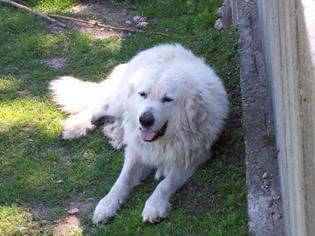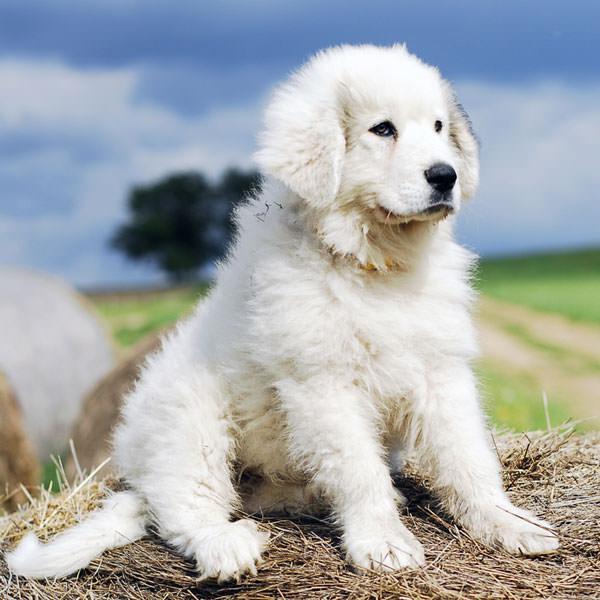The first image is the image on the left, the second image is the image on the right. Given the left and right images, does the statement "There are no more than two dogs." hold true? Answer yes or no. Yes. The first image is the image on the left, the second image is the image on the right. For the images displayed, is the sentence "There is exactly one dog in each image." factually correct? Answer yes or no. Yes. 